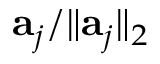<formula> <loc_0><loc_0><loc_500><loc_500>a _ { j } / \| a _ { j } \| _ { 2 }</formula> 